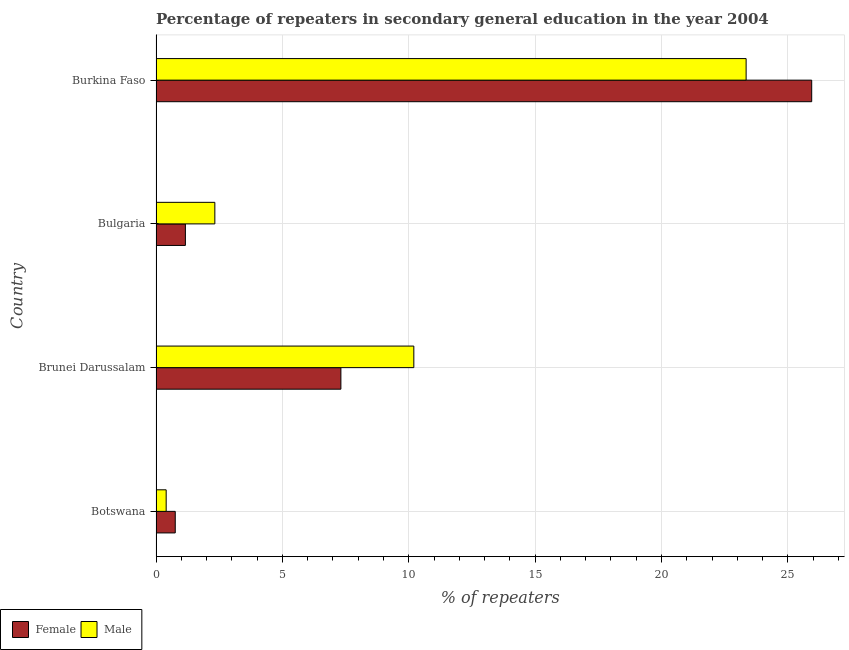How many different coloured bars are there?
Your answer should be very brief. 2. How many bars are there on the 3rd tick from the top?
Offer a very short reply. 2. How many bars are there on the 3rd tick from the bottom?
Your answer should be very brief. 2. What is the label of the 3rd group of bars from the top?
Your answer should be very brief. Brunei Darussalam. In how many cases, is the number of bars for a given country not equal to the number of legend labels?
Offer a very short reply. 0. What is the percentage of female repeaters in Burkina Faso?
Offer a terse response. 25.94. Across all countries, what is the maximum percentage of male repeaters?
Offer a terse response. 23.35. Across all countries, what is the minimum percentage of female repeaters?
Provide a succinct answer. 0.76. In which country was the percentage of female repeaters maximum?
Give a very brief answer. Burkina Faso. In which country was the percentage of female repeaters minimum?
Ensure brevity in your answer.  Botswana. What is the total percentage of male repeaters in the graph?
Keep it short and to the point. 36.28. What is the difference between the percentage of male repeaters in Brunei Darussalam and that in Burkina Faso?
Offer a terse response. -13.15. What is the difference between the percentage of female repeaters in Bulgaria and the percentage of male repeaters in Brunei Darussalam?
Ensure brevity in your answer.  -9.04. What is the average percentage of male repeaters per country?
Your answer should be compact. 9.07. What is the difference between the percentage of female repeaters and percentage of male repeaters in Brunei Darussalam?
Give a very brief answer. -2.89. In how many countries, is the percentage of male repeaters greater than 16 %?
Ensure brevity in your answer.  1. What is the ratio of the percentage of female repeaters in Brunei Darussalam to that in Bulgaria?
Ensure brevity in your answer.  6.29. What is the difference between the highest and the second highest percentage of male repeaters?
Offer a terse response. 13.15. What is the difference between the highest and the lowest percentage of male repeaters?
Give a very brief answer. 22.95. Is the sum of the percentage of male repeaters in Brunei Darussalam and Bulgaria greater than the maximum percentage of female repeaters across all countries?
Give a very brief answer. No. What does the 1st bar from the top in Bulgaria represents?
Offer a terse response. Male. Are all the bars in the graph horizontal?
Your answer should be compact. Yes. How many countries are there in the graph?
Make the answer very short. 4. What is the difference between two consecutive major ticks on the X-axis?
Offer a terse response. 5. Does the graph contain any zero values?
Provide a succinct answer. No. Does the graph contain grids?
Give a very brief answer. Yes. Where does the legend appear in the graph?
Give a very brief answer. Bottom left. How many legend labels are there?
Make the answer very short. 2. How are the legend labels stacked?
Offer a terse response. Horizontal. What is the title of the graph?
Make the answer very short. Percentage of repeaters in secondary general education in the year 2004. Does "Public credit registry" appear as one of the legend labels in the graph?
Give a very brief answer. No. What is the label or title of the X-axis?
Provide a succinct answer. % of repeaters. What is the % of repeaters in Female in Botswana?
Offer a very short reply. 0.76. What is the % of repeaters in Male in Botswana?
Provide a short and direct response. 0.4. What is the % of repeaters of Female in Brunei Darussalam?
Your answer should be compact. 7.31. What is the % of repeaters in Male in Brunei Darussalam?
Your response must be concise. 10.2. What is the % of repeaters in Female in Bulgaria?
Keep it short and to the point. 1.16. What is the % of repeaters in Male in Bulgaria?
Give a very brief answer. 2.33. What is the % of repeaters in Female in Burkina Faso?
Make the answer very short. 25.94. What is the % of repeaters in Male in Burkina Faso?
Provide a succinct answer. 23.35. Across all countries, what is the maximum % of repeaters of Female?
Provide a short and direct response. 25.94. Across all countries, what is the maximum % of repeaters of Male?
Offer a terse response. 23.35. Across all countries, what is the minimum % of repeaters in Female?
Ensure brevity in your answer.  0.76. Across all countries, what is the minimum % of repeaters of Male?
Ensure brevity in your answer.  0.4. What is the total % of repeaters in Female in the graph?
Keep it short and to the point. 35.18. What is the total % of repeaters of Male in the graph?
Offer a terse response. 36.28. What is the difference between the % of repeaters in Female in Botswana and that in Brunei Darussalam?
Your answer should be compact. -6.55. What is the difference between the % of repeaters of Male in Botswana and that in Brunei Darussalam?
Offer a terse response. -9.8. What is the difference between the % of repeaters in Female in Botswana and that in Bulgaria?
Ensure brevity in your answer.  -0.4. What is the difference between the % of repeaters in Male in Botswana and that in Bulgaria?
Offer a terse response. -1.93. What is the difference between the % of repeaters of Female in Botswana and that in Burkina Faso?
Offer a terse response. -25.18. What is the difference between the % of repeaters of Male in Botswana and that in Burkina Faso?
Offer a terse response. -22.95. What is the difference between the % of repeaters in Female in Brunei Darussalam and that in Bulgaria?
Make the answer very short. 6.15. What is the difference between the % of repeaters of Male in Brunei Darussalam and that in Bulgaria?
Give a very brief answer. 7.87. What is the difference between the % of repeaters of Female in Brunei Darussalam and that in Burkina Faso?
Keep it short and to the point. -18.63. What is the difference between the % of repeaters in Male in Brunei Darussalam and that in Burkina Faso?
Offer a terse response. -13.15. What is the difference between the % of repeaters of Female in Bulgaria and that in Burkina Faso?
Make the answer very short. -24.78. What is the difference between the % of repeaters in Male in Bulgaria and that in Burkina Faso?
Keep it short and to the point. -21.02. What is the difference between the % of repeaters of Female in Botswana and the % of repeaters of Male in Brunei Darussalam?
Your response must be concise. -9.44. What is the difference between the % of repeaters in Female in Botswana and the % of repeaters in Male in Bulgaria?
Your answer should be very brief. -1.57. What is the difference between the % of repeaters in Female in Botswana and the % of repeaters in Male in Burkina Faso?
Make the answer very short. -22.59. What is the difference between the % of repeaters of Female in Brunei Darussalam and the % of repeaters of Male in Bulgaria?
Keep it short and to the point. 4.99. What is the difference between the % of repeaters in Female in Brunei Darussalam and the % of repeaters in Male in Burkina Faso?
Your response must be concise. -16.03. What is the difference between the % of repeaters in Female in Bulgaria and the % of repeaters in Male in Burkina Faso?
Offer a very short reply. -22.19. What is the average % of repeaters of Female per country?
Provide a succinct answer. 8.8. What is the average % of repeaters in Male per country?
Your answer should be compact. 9.07. What is the difference between the % of repeaters in Female and % of repeaters in Male in Botswana?
Give a very brief answer. 0.36. What is the difference between the % of repeaters in Female and % of repeaters in Male in Brunei Darussalam?
Your answer should be compact. -2.89. What is the difference between the % of repeaters in Female and % of repeaters in Male in Bulgaria?
Your response must be concise. -1.17. What is the difference between the % of repeaters of Female and % of repeaters of Male in Burkina Faso?
Provide a succinct answer. 2.6. What is the ratio of the % of repeaters in Female in Botswana to that in Brunei Darussalam?
Make the answer very short. 0.1. What is the ratio of the % of repeaters of Male in Botswana to that in Brunei Darussalam?
Provide a short and direct response. 0.04. What is the ratio of the % of repeaters in Female in Botswana to that in Bulgaria?
Your answer should be very brief. 0.65. What is the ratio of the % of repeaters of Male in Botswana to that in Bulgaria?
Your response must be concise. 0.17. What is the ratio of the % of repeaters of Female in Botswana to that in Burkina Faso?
Offer a terse response. 0.03. What is the ratio of the % of repeaters of Male in Botswana to that in Burkina Faso?
Offer a very short reply. 0.02. What is the ratio of the % of repeaters in Female in Brunei Darussalam to that in Bulgaria?
Make the answer very short. 6.29. What is the ratio of the % of repeaters in Male in Brunei Darussalam to that in Bulgaria?
Make the answer very short. 4.38. What is the ratio of the % of repeaters of Female in Brunei Darussalam to that in Burkina Faso?
Offer a terse response. 0.28. What is the ratio of the % of repeaters of Male in Brunei Darussalam to that in Burkina Faso?
Keep it short and to the point. 0.44. What is the ratio of the % of repeaters of Female in Bulgaria to that in Burkina Faso?
Your response must be concise. 0.04. What is the ratio of the % of repeaters in Male in Bulgaria to that in Burkina Faso?
Keep it short and to the point. 0.1. What is the difference between the highest and the second highest % of repeaters of Female?
Make the answer very short. 18.63. What is the difference between the highest and the second highest % of repeaters of Male?
Make the answer very short. 13.15. What is the difference between the highest and the lowest % of repeaters of Female?
Ensure brevity in your answer.  25.18. What is the difference between the highest and the lowest % of repeaters of Male?
Your response must be concise. 22.95. 